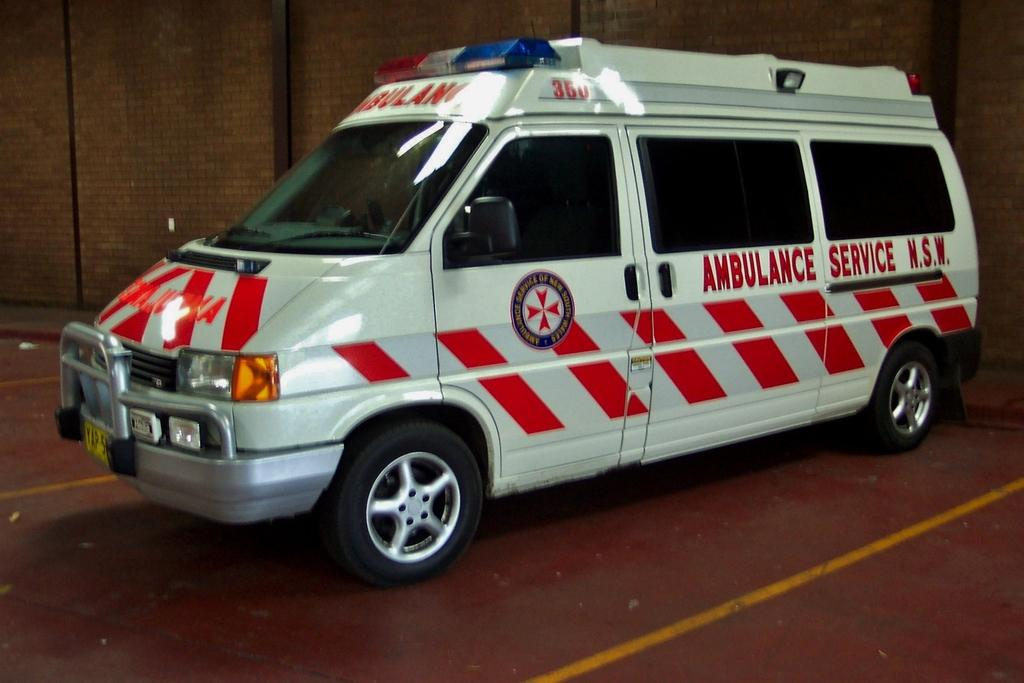<image>
Summarize the visual content of the image. an ambulance with the words 'ambulance service N.S.W. on its side.' 